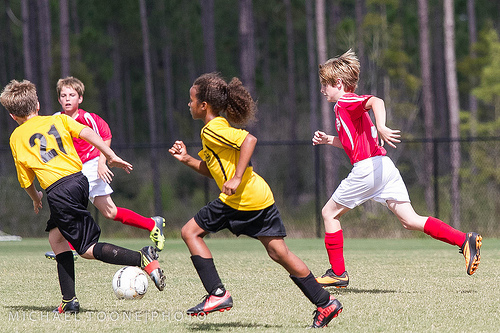<image>
Is the boy on the ball? No. The boy is not positioned on the ball. They may be near each other, but the boy is not supported by or resting on top of the ball. Where is the shirt in relation to the girl? Is it on the girl? No. The shirt is not positioned on the girl. They may be near each other, but the shirt is not supported by or resting on top of the girl. Where is the shoe in relation to the ball? Is it behind the ball? Yes. From this viewpoint, the shoe is positioned behind the ball, with the ball partially or fully occluding the shoe. 